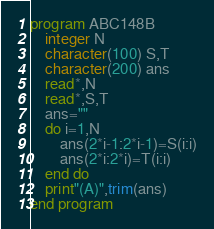Convert code to text. <code><loc_0><loc_0><loc_500><loc_500><_FORTRAN_>program ABC148B
    integer N
    character(100) S,T
    character(200) ans
    read*,N
    read*,S,T
    ans=""
    do i=1,N
        ans(2*i-1:2*i-1)=S(i:i)
        ans(2*i:2*i)=T(i:i)
    end do
    print"(A)",trim(ans)
end program</code> 